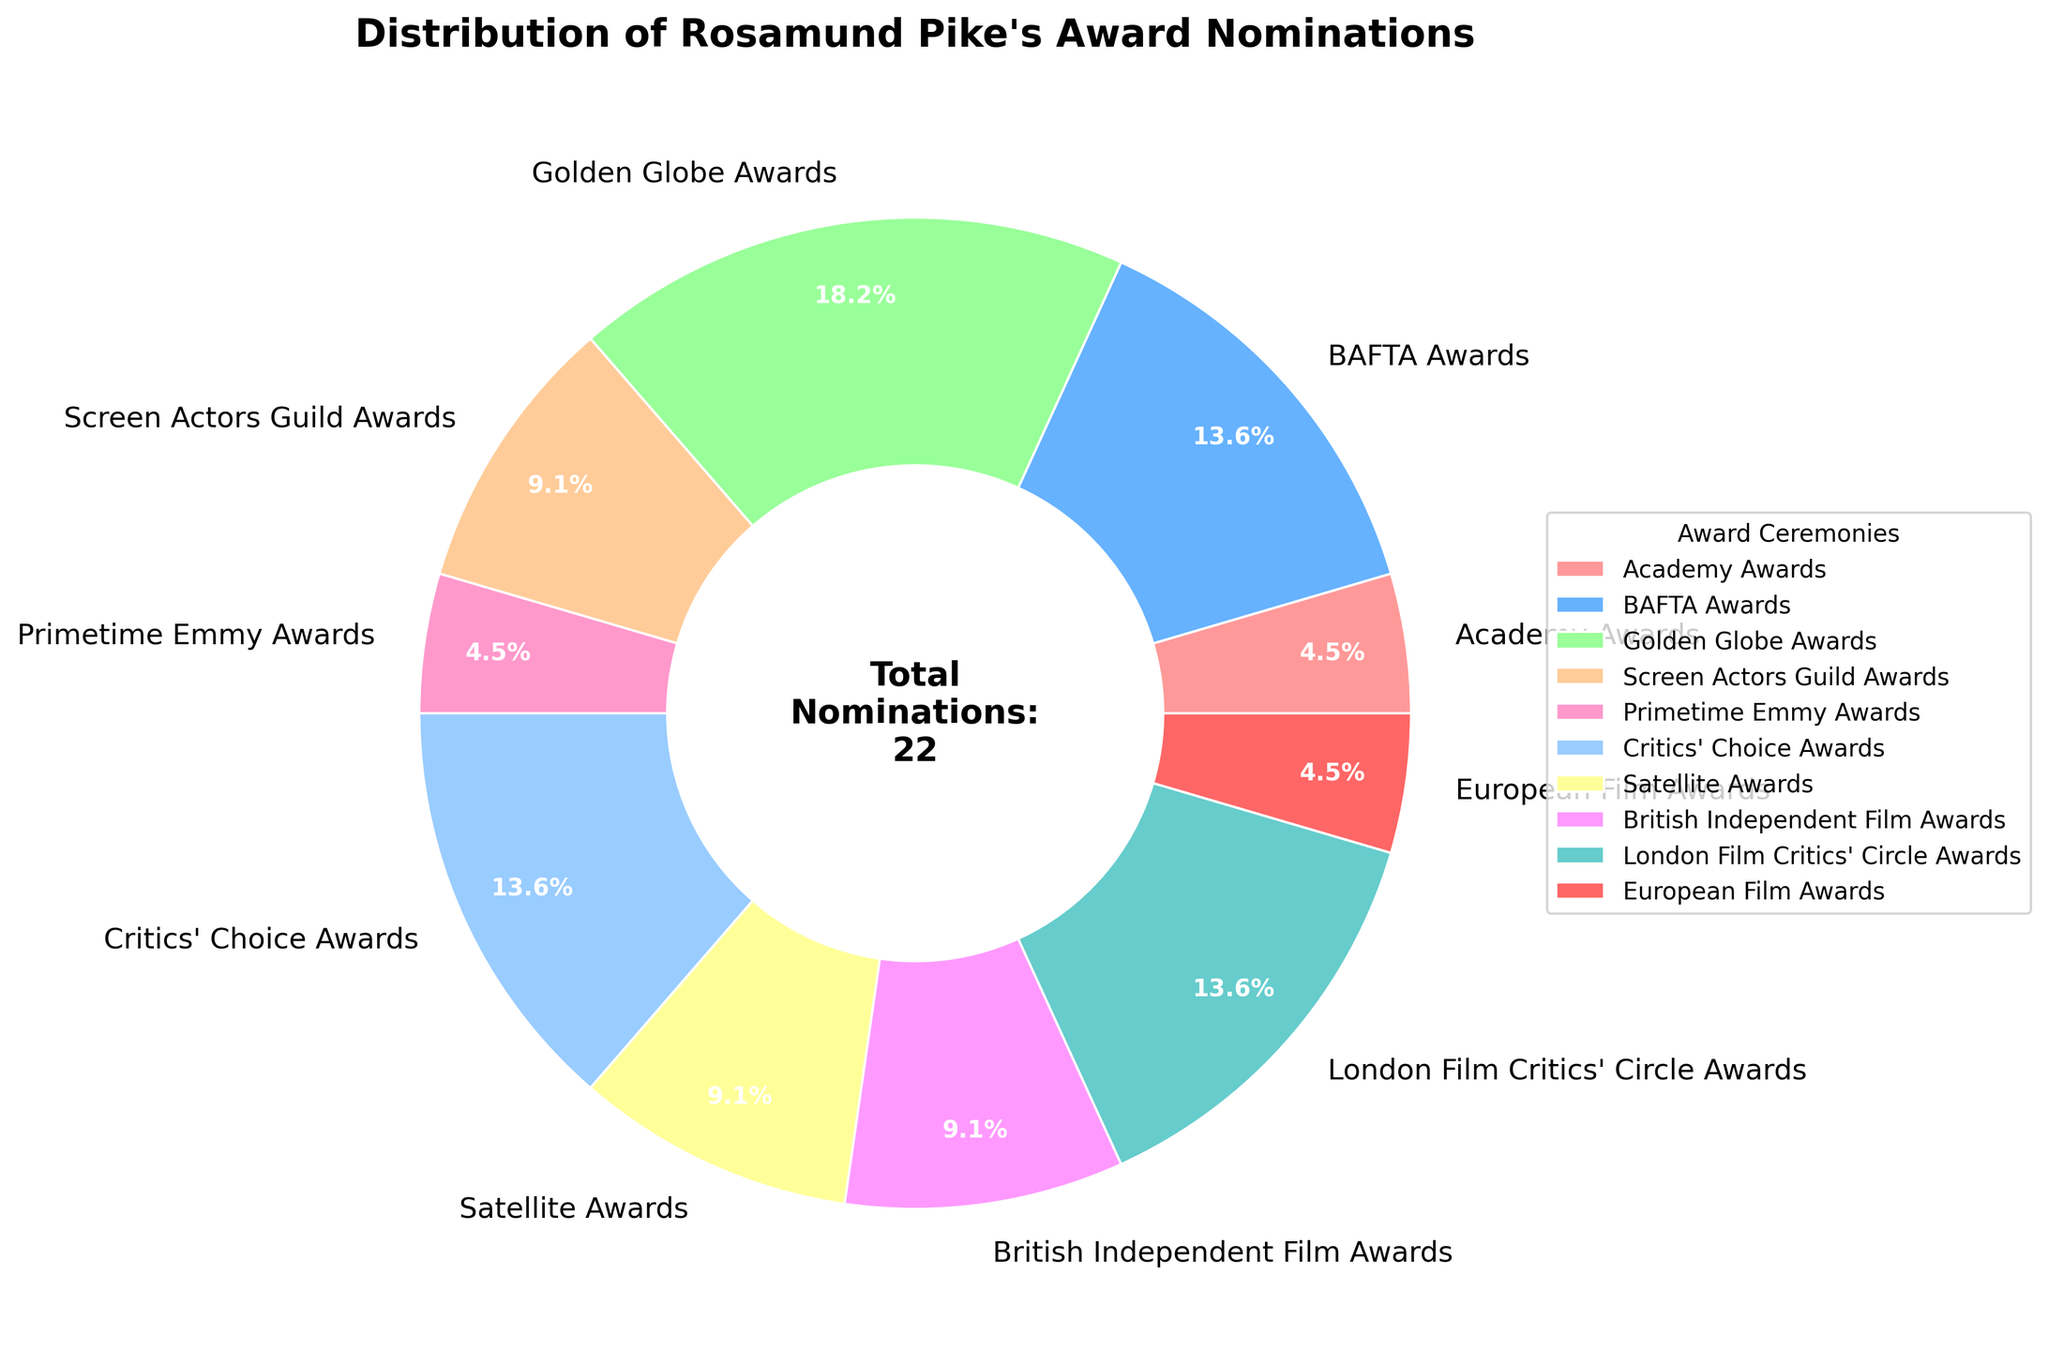Which award ceremony has the highest number of nominations? The pie chart shows the number of nominations for each award ceremony. The biggest segment corresponds to the Golden Globe Awards.
Answer: Golden Globe Awards How many total nominations has Rosamund Pike received? There's a text in the center of the pie chart stating the total number of nominations.
Answer: 22 What percentage of nominations does Rosamund Pike have for the BAFTA Awards? Find the segment labeled "BAFTA Awards" and read its percentage from the chart.
Answer: 13.6% Which award ceremony has more nominations: Screen Actors Guild Awards or Critics' Choice Awards? Compare the segments labeled "Screen Actors Guild Awards" and "Critics' Choice Awards". The Critics' Choice Awards segment is slightly larger.
Answer: Critics' Choice Awards What is the combined percentage of nominations for the Academy Awards, Primetime Emmy Awards, and European Film Awards? Add the percentages for these three award ceremonies. Academy Awards: 4.5%, Primetime Emmy Awards: 4.5%, European Film Awards: 4.5%. Total: 4.5% + 4.5% + 4.5% = 13.5%.
Answer: 13.5% What is the smallest category in terms of the number of nominations? Identify the smallest segment in the pie chart, corresponding to the Academy Awards, Primetime Emmy Awards, and European Film Awards, all have one nomination each. Any one of these can be considered the correct answer.
Answer: Academy Awards, Primetime Emmy Awards, or European Film Awards How many award ceremonies did Rosamund Pike receive at least two nominations? Count the segments representing at least two nominations: Screen Actors Guild Awards, Critics' Choice Awards, Satellite Awards, British Independent Film Awards, BAFTA Awards, Golden Globe Awards, London Film Critics' Circle Awards, which makes 7.
Answer: 7 What is the difference in nominations between the Golden Globe Awards and the Satellite Awards? Golden Globe Awards have 4 nominations, and Satellite Awards have 2 nominations. Difference = 4 - 2 = 2.
Answer: 2 Which award ceremonies have exactly 2 nominations for Rosamund Pike? Identify segments with 2 nominations: Screen Actors Guild Awards, Satellite Awards, British Independent Film Awards.
Answer: Screen Actors Guild Awards, Satellite Awards, British Independent Film Awards Among the BAFTA Awards, Golden Globe Awards, and London Film Critics' Circle Awards, which has the highest nominations? Compare the three segments: BAFTA Awards (3), Golden Globe Awards (4), and London Film Critics' Circle Awards (3). The Golden Globe Awards segment is larger.
Answer: Golden Globe Awards 